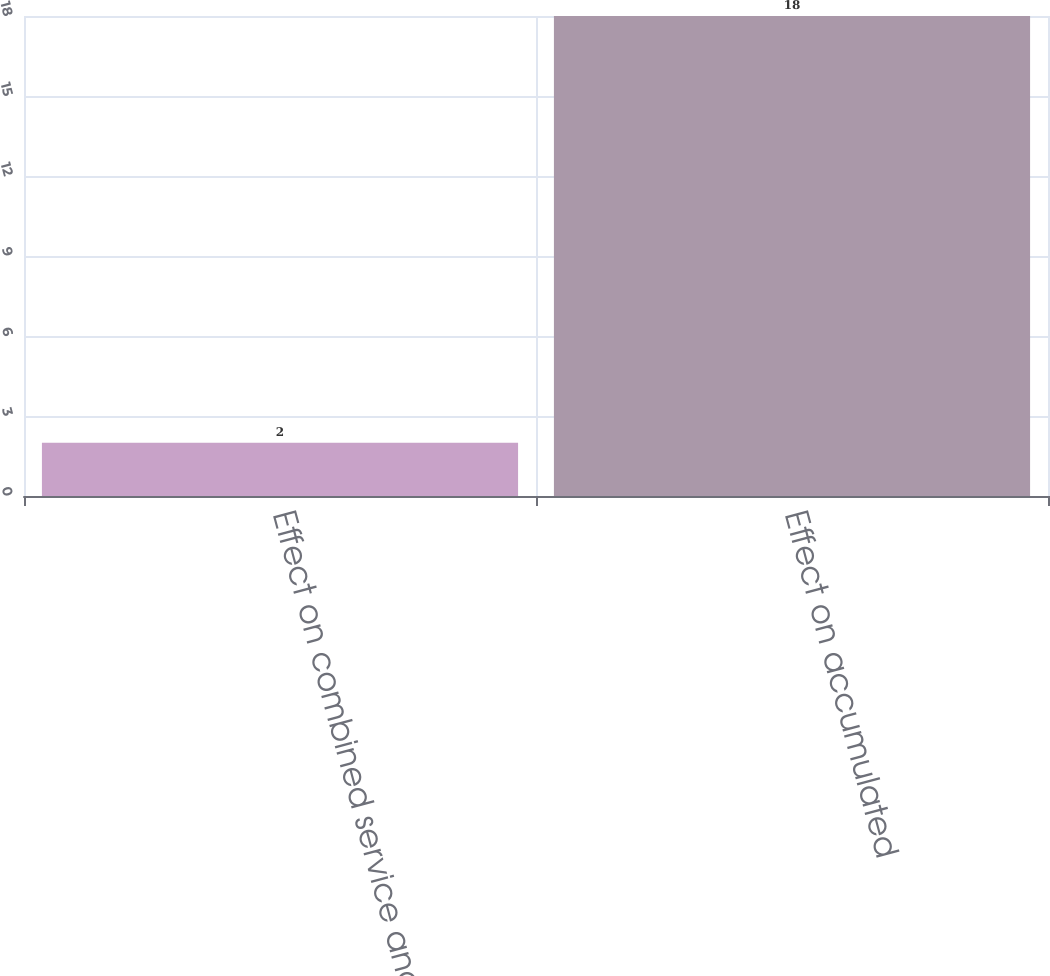<chart> <loc_0><loc_0><loc_500><loc_500><bar_chart><fcel>Effect on combined service and<fcel>Effect on accumulated<nl><fcel>2<fcel>18<nl></chart> 